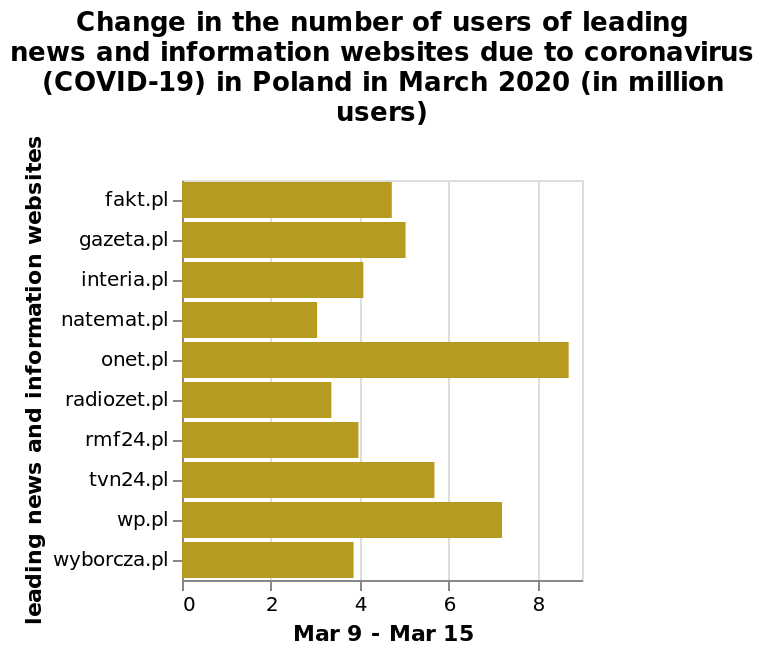<image>
Which week of March does the bar chart represent? The bar chart represents the week of March 9 to March 15. please describe the details of the chart Here a is a bar chart named Change in the number of users of leading news and information websites due to coronavirus (COVID-19) in Poland in March 2020 (in million users). The x-axis plots Mar 9 - Mar 15 with linear scale with a minimum of 0 and a maximum of 8 while the y-axis measures  leading news and information websites on categorical scale from fakt.pl to wyborcza.pl. What is the title of the bar chart?  The title of the bar chart is "Change in the number of users of leading news and information websites due to coronavirus (COVID-19) in Poland in March 2020 (in million users)". Offer a thorough analysis of the image. All 10 of the leading news and information websites depicted experienced an increase in users in the March 9 - 15th period. onet.pl had the largest increase, at 9 million users. natemat.pl had the smallest increase, at 3 million users. 